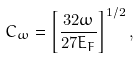Convert formula to latex. <formula><loc_0><loc_0><loc_500><loc_500>C _ { \omega } = \left [ \frac { 3 2 \omega } { 2 7 E _ { F } } \right ] ^ { 1 / 2 } ,</formula> 